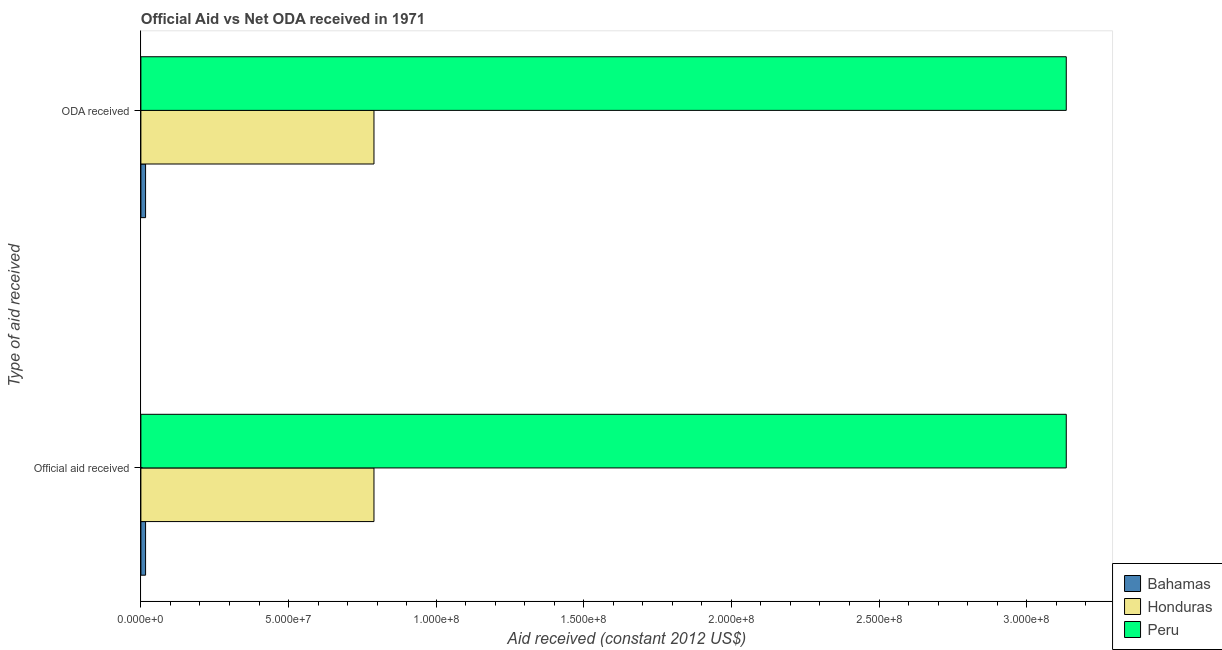Are the number of bars per tick equal to the number of legend labels?
Provide a short and direct response. Yes. Are the number of bars on each tick of the Y-axis equal?
Your response must be concise. Yes. How many bars are there on the 2nd tick from the top?
Keep it short and to the point. 3. What is the label of the 2nd group of bars from the top?
Your answer should be compact. Official aid received. What is the oda received in Honduras?
Ensure brevity in your answer.  7.89e+07. Across all countries, what is the maximum official aid received?
Offer a terse response. 3.13e+08. Across all countries, what is the minimum official aid received?
Provide a short and direct response. 1.59e+06. In which country was the oda received minimum?
Your answer should be compact. Bahamas. What is the total official aid received in the graph?
Make the answer very short. 3.94e+08. What is the difference between the oda received in Honduras and that in Peru?
Give a very brief answer. -2.34e+08. What is the difference between the oda received in Peru and the official aid received in Bahamas?
Offer a terse response. 3.12e+08. What is the average oda received per country?
Give a very brief answer. 1.31e+08. What is the difference between the oda received and official aid received in Peru?
Offer a very short reply. 0. What is the ratio of the oda received in Peru to that in Honduras?
Provide a short and direct response. 3.97. In how many countries, is the official aid received greater than the average official aid received taken over all countries?
Provide a short and direct response. 1. What does the 3rd bar from the top in ODA received represents?
Keep it short and to the point. Bahamas. What is the difference between two consecutive major ticks on the X-axis?
Make the answer very short. 5.00e+07. Are the values on the major ticks of X-axis written in scientific E-notation?
Your answer should be very brief. Yes. Does the graph contain grids?
Provide a short and direct response. No. Where does the legend appear in the graph?
Give a very brief answer. Bottom right. How are the legend labels stacked?
Your answer should be compact. Vertical. What is the title of the graph?
Your answer should be compact. Official Aid vs Net ODA received in 1971 . Does "Micronesia" appear as one of the legend labels in the graph?
Offer a very short reply. No. What is the label or title of the X-axis?
Give a very brief answer. Aid received (constant 2012 US$). What is the label or title of the Y-axis?
Ensure brevity in your answer.  Type of aid received. What is the Aid received (constant 2012 US$) of Bahamas in Official aid received?
Your response must be concise. 1.59e+06. What is the Aid received (constant 2012 US$) of Honduras in Official aid received?
Provide a succinct answer. 7.89e+07. What is the Aid received (constant 2012 US$) in Peru in Official aid received?
Ensure brevity in your answer.  3.13e+08. What is the Aid received (constant 2012 US$) of Bahamas in ODA received?
Your answer should be very brief. 1.59e+06. What is the Aid received (constant 2012 US$) of Honduras in ODA received?
Make the answer very short. 7.89e+07. What is the Aid received (constant 2012 US$) of Peru in ODA received?
Your answer should be compact. 3.13e+08. Across all Type of aid received, what is the maximum Aid received (constant 2012 US$) in Bahamas?
Give a very brief answer. 1.59e+06. Across all Type of aid received, what is the maximum Aid received (constant 2012 US$) of Honduras?
Keep it short and to the point. 7.89e+07. Across all Type of aid received, what is the maximum Aid received (constant 2012 US$) in Peru?
Your response must be concise. 3.13e+08. Across all Type of aid received, what is the minimum Aid received (constant 2012 US$) in Bahamas?
Offer a terse response. 1.59e+06. Across all Type of aid received, what is the minimum Aid received (constant 2012 US$) of Honduras?
Make the answer very short. 7.89e+07. Across all Type of aid received, what is the minimum Aid received (constant 2012 US$) in Peru?
Your answer should be very brief. 3.13e+08. What is the total Aid received (constant 2012 US$) in Bahamas in the graph?
Ensure brevity in your answer.  3.18e+06. What is the total Aid received (constant 2012 US$) in Honduras in the graph?
Keep it short and to the point. 1.58e+08. What is the total Aid received (constant 2012 US$) in Peru in the graph?
Your answer should be compact. 6.27e+08. What is the difference between the Aid received (constant 2012 US$) of Bahamas in Official aid received and that in ODA received?
Your answer should be compact. 0. What is the difference between the Aid received (constant 2012 US$) in Peru in Official aid received and that in ODA received?
Offer a very short reply. 0. What is the difference between the Aid received (constant 2012 US$) of Bahamas in Official aid received and the Aid received (constant 2012 US$) of Honduras in ODA received?
Your answer should be very brief. -7.74e+07. What is the difference between the Aid received (constant 2012 US$) of Bahamas in Official aid received and the Aid received (constant 2012 US$) of Peru in ODA received?
Give a very brief answer. -3.12e+08. What is the difference between the Aid received (constant 2012 US$) of Honduras in Official aid received and the Aid received (constant 2012 US$) of Peru in ODA received?
Provide a short and direct response. -2.34e+08. What is the average Aid received (constant 2012 US$) in Bahamas per Type of aid received?
Ensure brevity in your answer.  1.59e+06. What is the average Aid received (constant 2012 US$) of Honduras per Type of aid received?
Offer a very short reply. 7.89e+07. What is the average Aid received (constant 2012 US$) of Peru per Type of aid received?
Provide a short and direct response. 3.13e+08. What is the difference between the Aid received (constant 2012 US$) in Bahamas and Aid received (constant 2012 US$) in Honduras in Official aid received?
Ensure brevity in your answer.  -7.74e+07. What is the difference between the Aid received (constant 2012 US$) in Bahamas and Aid received (constant 2012 US$) in Peru in Official aid received?
Offer a very short reply. -3.12e+08. What is the difference between the Aid received (constant 2012 US$) in Honduras and Aid received (constant 2012 US$) in Peru in Official aid received?
Provide a short and direct response. -2.34e+08. What is the difference between the Aid received (constant 2012 US$) in Bahamas and Aid received (constant 2012 US$) in Honduras in ODA received?
Your answer should be very brief. -7.74e+07. What is the difference between the Aid received (constant 2012 US$) in Bahamas and Aid received (constant 2012 US$) in Peru in ODA received?
Offer a very short reply. -3.12e+08. What is the difference between the Aid received (constant 2012 US$) in Honduras and Aid received (constant 2012 US$) in Peru in ODA received?
Provide a short and direct response. -2.34e+08. What is the difference between the highest and the second highest Aid received (constant 2012 US$) in Honduras?
Offer a terse response. 0. What is the difference between the highest and the lowest Aid received (constant 2012 US$) in Honduras?
Your answer should be compact. 0. What is the difference between the highest and the lowest Aid received (constant 2012 US$) in Peru?
Provide a succinct answer. 0. 